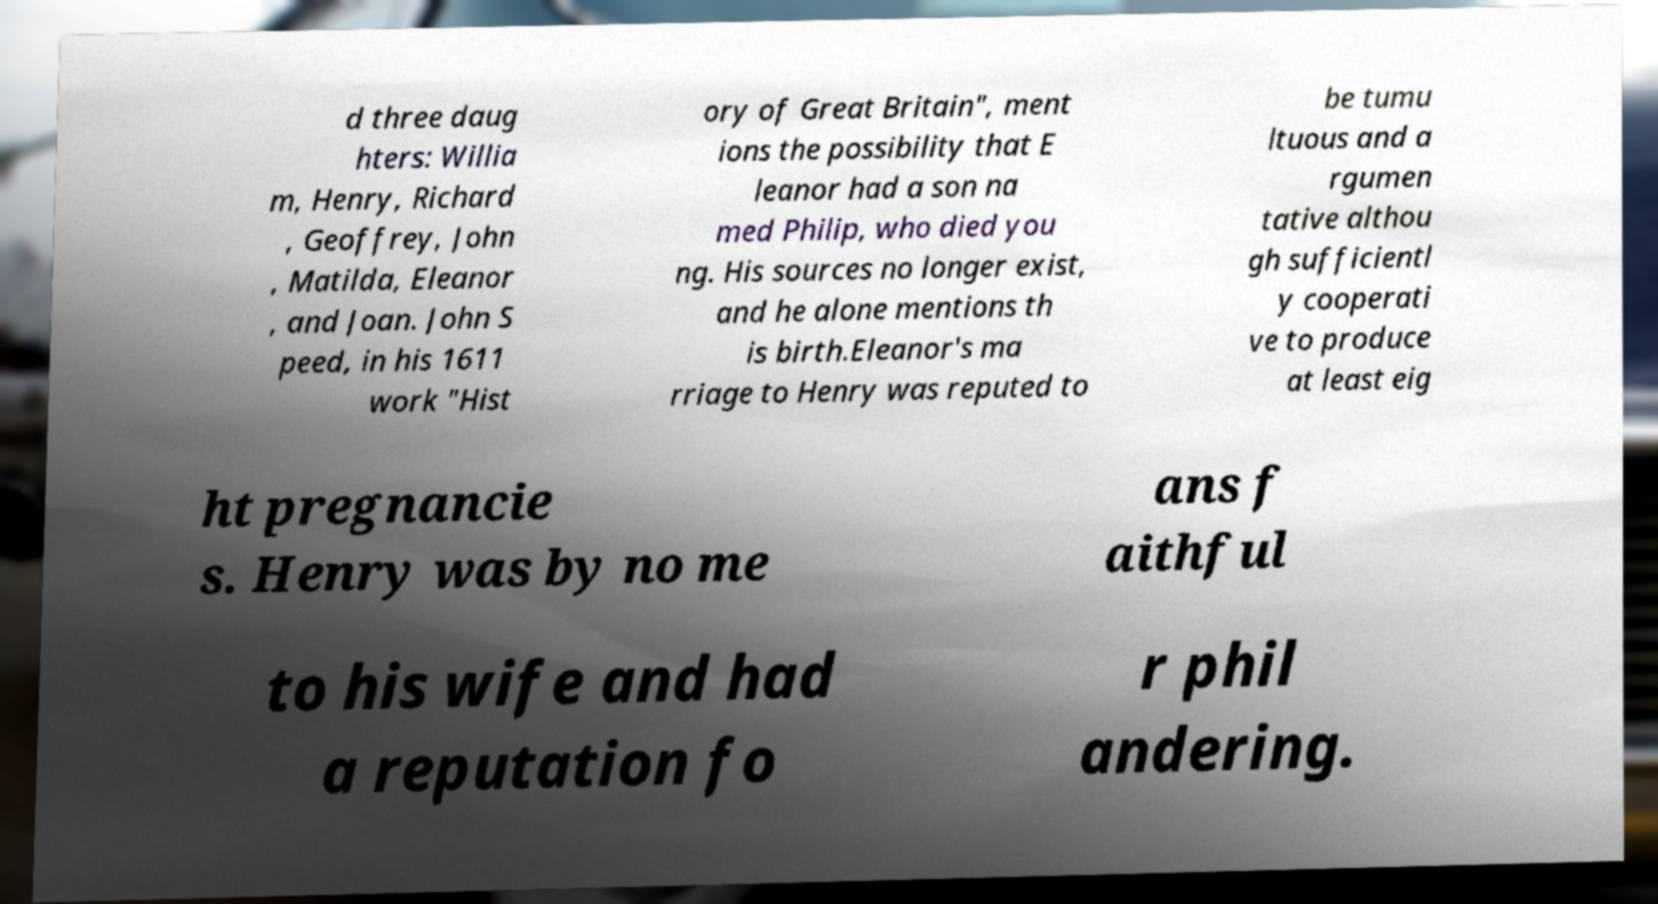I need the written content from this picture converted into text. Can you do that? d three daug hters: Willia m, Henry, Richard , Geoffrey, John , Matilda, Eleanor , and Joan. John S peed, in his 1611 work "Hist ory of Great Britain", ment ions the possibility that E leanor had a son na med Philip, who died you ng. His sources no longer exist, and he alone mentions th is birth.Eleanor's ma rriage to Henry was reputed to be tumu ltuous and a rgumen tative althou gh sufficientl y cooperati ve to produce at least eig ht pregnancie s. Henry was by no me ans f aithful to his wife and had a reputation fo r phil andering. 